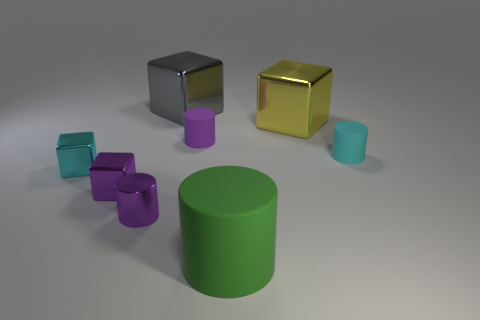What materials appear to be represented by the objects in the image? The objects in the image seem to have a variety of textures that suggest they are made from different materials. The two cubes appear to have a metallic finish, indicating they could represent metal materials. The cylinders, including the larger one and the small ones behind it, have a matte finish suggesting a plastic or rubber-like material. 